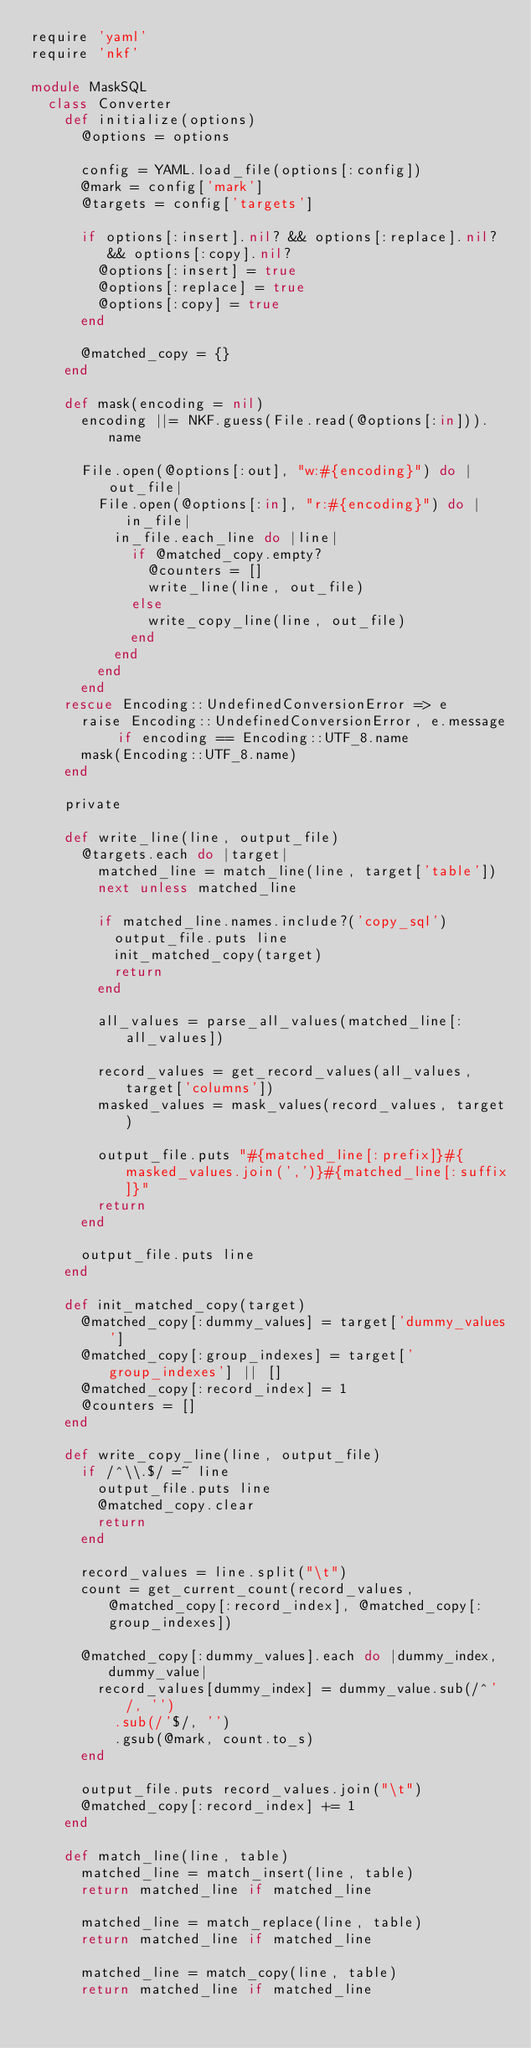Convert code to text. <code><loc_0><loc_0><loc_500><loc_500><_Ruby_>require 'yaml'
require 'nkf'

module MaskSQL
  class Converter
    def initialize(options)
      @options = options

      config = YAML.load_file(options[:config])
      @mark = config['mark']
      @targets = config['targets']

      if options[:insert].nil? && options[:replace].nil? && options[:copy].nil?
        @options[:insert] = true
        @options[:replace] = true
        @options[:copy] = true
      end

      @matched_copy = {}
    end

    def mask(encoding = nil)
      encoding ||= NKF.guess(File.read(@options[:in])).name

      File.open(@options[:out], "w:#{encoding}") do |out_file|
        File.open(@options[:in], "r:#{encoding}") do |in_file|
          in_file.each_line do |line|
            if @matched_copy.empty?
              @counters = []
              write_line(line, out_file)
            else
              write_copy_line(line, out_file)
            end
          end
        end
      end
    rescue Encoding::UndefinedConversionError => e
      raise Encoding::UndefinedConversionError, e.message if encoding == Encoding::UTF_8.name
      mask(Encoding::UTF_8.name)
    end

    private

    def write_line(line, output_file)
      @targets.each do |target|
        matched_line = match_line(line, target['table'])
        next unless matched_line

        if matched_line.names.include?('copy_sql')
          output_file.puts line
          init_matched_copy(target)
          return
        end

        all_values = parse_all_values(matched_line[:all_values])

        record_values = get_record_values(all_values, target['columns'])
        masked_values = mask_values(record_values, target)

        output_file.puts "#{matched_line[:prefix]}#{masked_values.join(',')}#{matched_line[:suffix]}"
        return
      end

      output_file.puts line
    end

    def init_matched_copy(target)
      @matched_copy[:dummy_values] = target['dummy_values']
      @matched_copy[:group_indexes] = target['group_indexes'] || []
      @matched_copy[:record_index] = 1
      @counters = []
    end

    def write_copy_line(line, output_file)
      if /^\\.$/ =~ line
        output_file.puts line
        @matched_copy.clear
        return
      end

      record_values = line.split("\t")
      count = get_current_count(record_values, @matched_copy[:record_index], @matched_copy[:group_indexes])

      @matched_copy[:dummy_values].each do |dummy_index, dummy_value|
        record_values[dummy_index] = dummy_value.sub(/^'/, '')
          .sub(/'$/, '')
          .gsub(@mark, count.to_s)
      end

      output_file.puts record_values.join("\t")
      @matched_copy[:record_index] += 1
    end

    def match_line(line, table)
      matched_line = match_insert(line, table)
      return matched_line if matched_line

      matched_line = match_replace(line, table)
      return matched_line if matched_line

      matched_line = match_copy(line, table)
      return matched_line if matched_line
</code> 